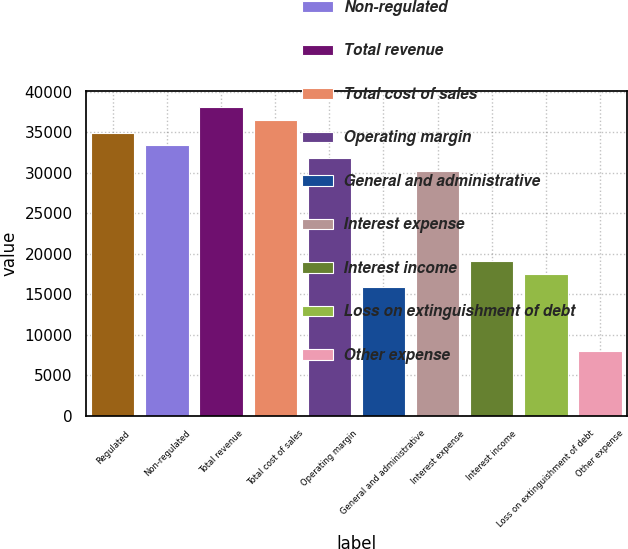Convert chart to OTSL. <chart><loc_0><loc_0><loc_500><loc_500><bar_chart><fcel>Regulated<fcel>Non-regulated<fcel>Total revenue<fcel>Total cost of sales<fcel>Operating margin<fcel>General and administrative<fcel>Interest expense<fcel>Interest income<fcel>Loss on extinguishment of debt<fcel>Other expense<nl><fcel>34960<fcel>33370.9<fcel>38138.2<fcel>36549.1<fcel>31781.8<fcel>15891<fcel>30192.8<fcel>19069.2<fcel>17480.1<fcel>7945.57<nl></chart> 